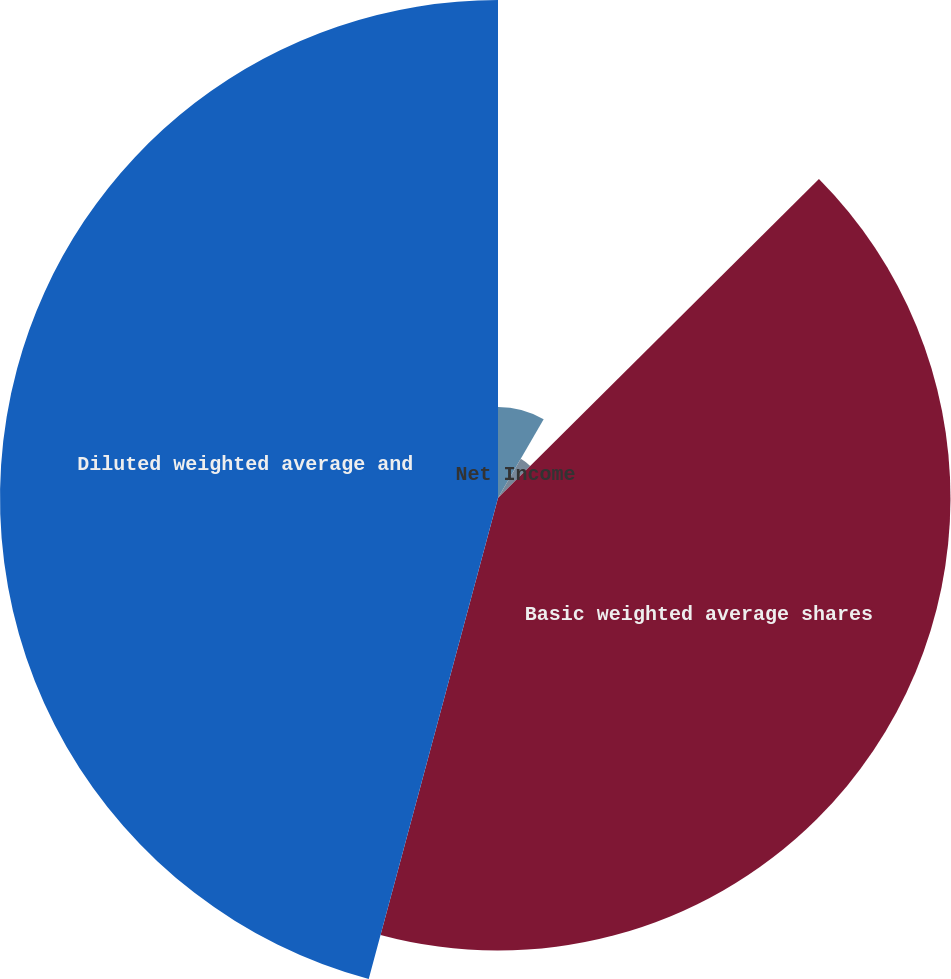Convert chart. <chart><loc_0><loc_0><loc_500><loc_500><pie_chart><fcel>Income from continuing<fcel>Income (loss) from<fcel>Net Income<fcel>Basic weighted average shares<fcel>Diluted weighted average and<nl><fcel>8.37%<fcel>0.0%<fcel>4.18%<fcel>41.63%<fcel>45.82%<nl></chart> 